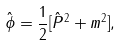<formula> <loc_0><loc_0><loc_500><loc_500>\hat { \phi } = \frac { 1 } { 2 } [ \hat { P } ^ { 2 } + m ^ { 2 } ] ,</formula> 